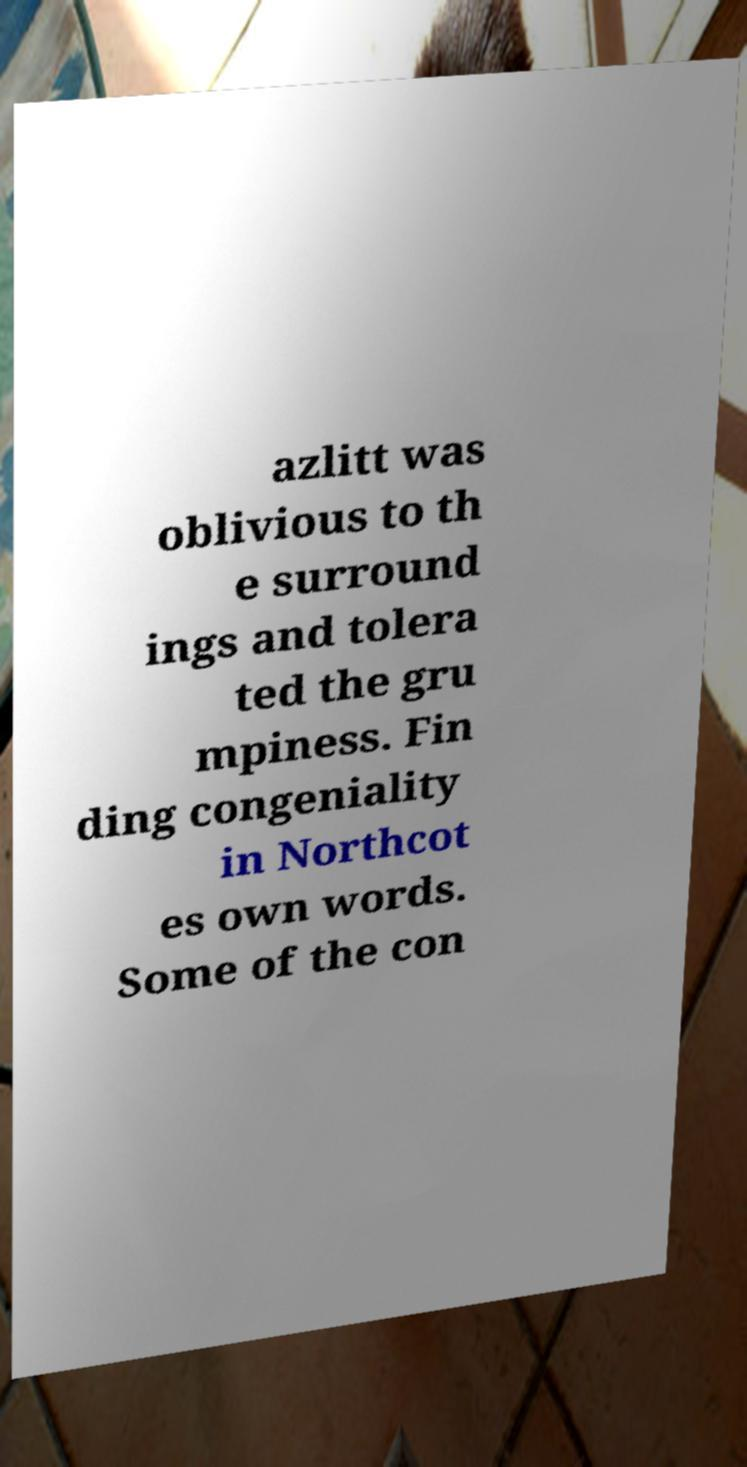I need the written content from this picture converted into text. Can you do that? azlitt was oblivious to th e surround ings and tolera ted the gru mpiness. Fin ding congeniality in Northcot es own words. Some of the con 